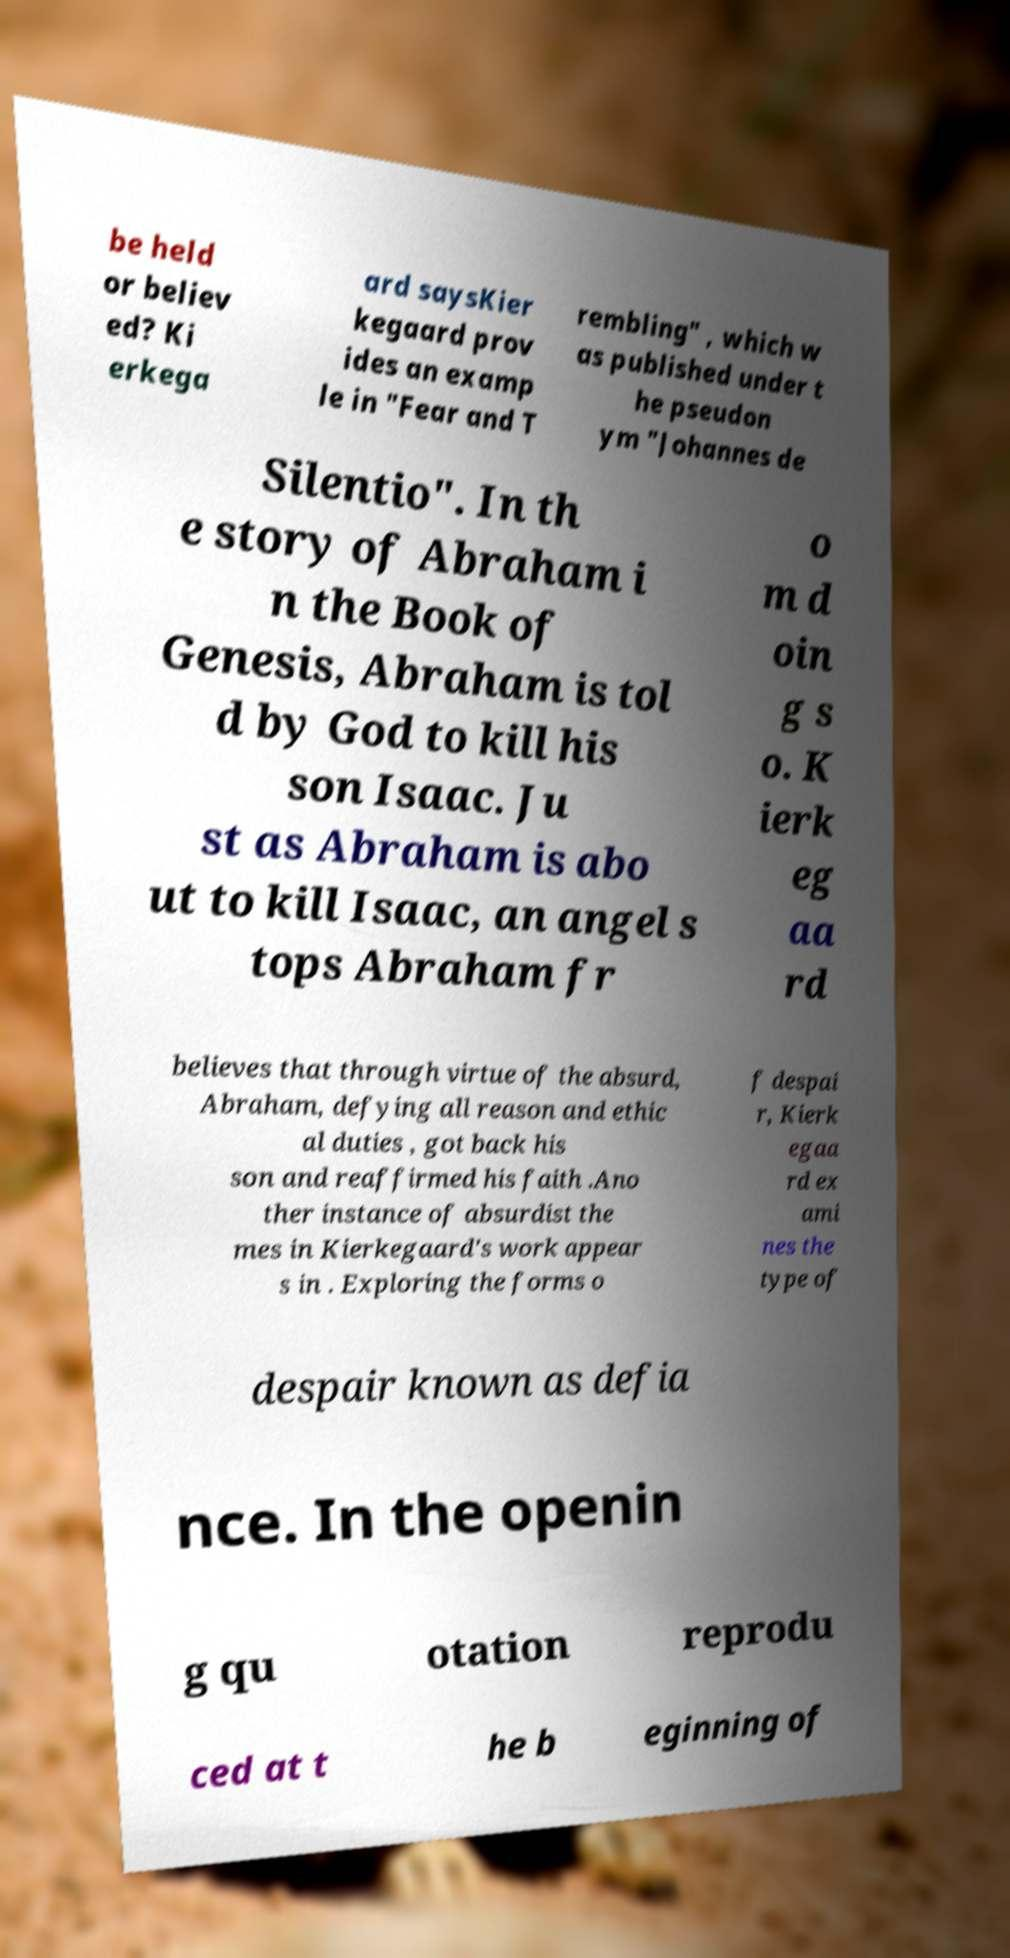There's text embedded in this image that I need extracted. Can you transcribe it verbatim? be held or believ ed? Ki erkega ard saysKier kegaard prov ides an examp le in "Fear and T rembling" , which w as published under t he pseudon ym "Johannes de Silentio". In th e story of Abraham i n the Book of Genesis, Abraham is tol d by God to kill his son Isaac. Ju st as Abraham is abo ut to kill Isaac, an angel s tops Abraham fr o m d oin g s o. K ierk eg aa rd believes that through virtue of the absurd, Abraham, defying all reason and ethic al duties , got back his son and reaffirmed his faith .Ano ther instance of absurdist the mes in Kierkegaard's work appear s in . Exploring the forms o f despai r, Kierk egaa rd ex ami nes the type of despair known as defia nce. In the openin g qu otation reprodu ced at t he b eginning of 